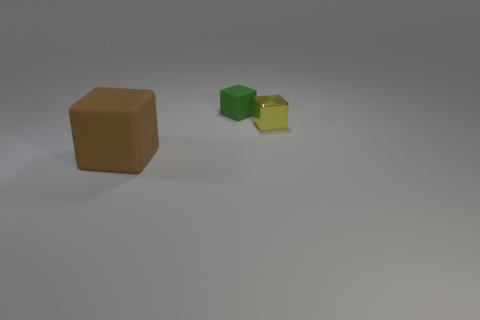What is the material of the block that is the same size as the yellow metallic object?
Offer a terse response. Rubber. What is the shape of the matte object that is on the right side of the thing to the left of the matte block behind the large matte block?
Your answer should be compact. Cube. The cube on the left side of the matte block right of the brown block is made of what material?
Give a very brief answer. Rubber. How many tiny metal cubes are behind the tiny green block?
Give a very brief answer. 0. Is there a large brown cube?
Offer a very short reply. Yes. What color is the rubber block behind the rubber cube left of the matte block that is behind the large rubber thing?
Give a very brief answer. Green. There is a tiny object in front of the tiny green object; is there a brown rubber cube behind it?
Provide a succinct answer. No. What number of yellow metallic things have the same size as the green matte cube?
Make the answer very short. 1. There is a block that is behind the yellow metallic cube; does it have the same size as the metallic cube?
Ensure brevity in your answer.  Yes. What shape is the large brown matte object?
Ensure brevity in your answer.  Cube. 